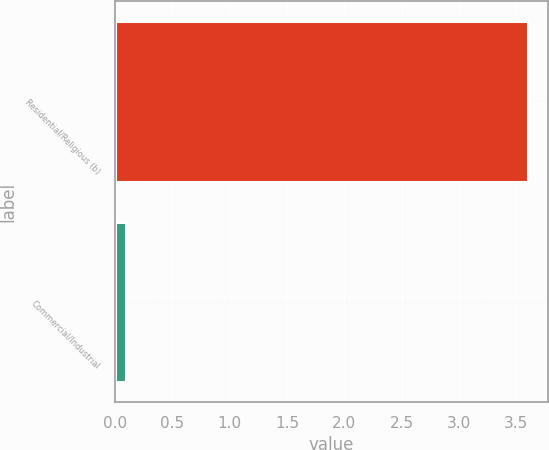Convert chart to OTSL. <chart><loc_0><loc_0><loc_500><loc_500><bar_chart><fcel>Residential/Religious (b)<fcel>Commercial/Industrial<nl><fcel>3.6<fcel>0.1<nl></chart> 